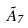<formula> <loc_0><loc_0><loc_500><loc_500>\tilde { A } _ { 7 }</formula> 